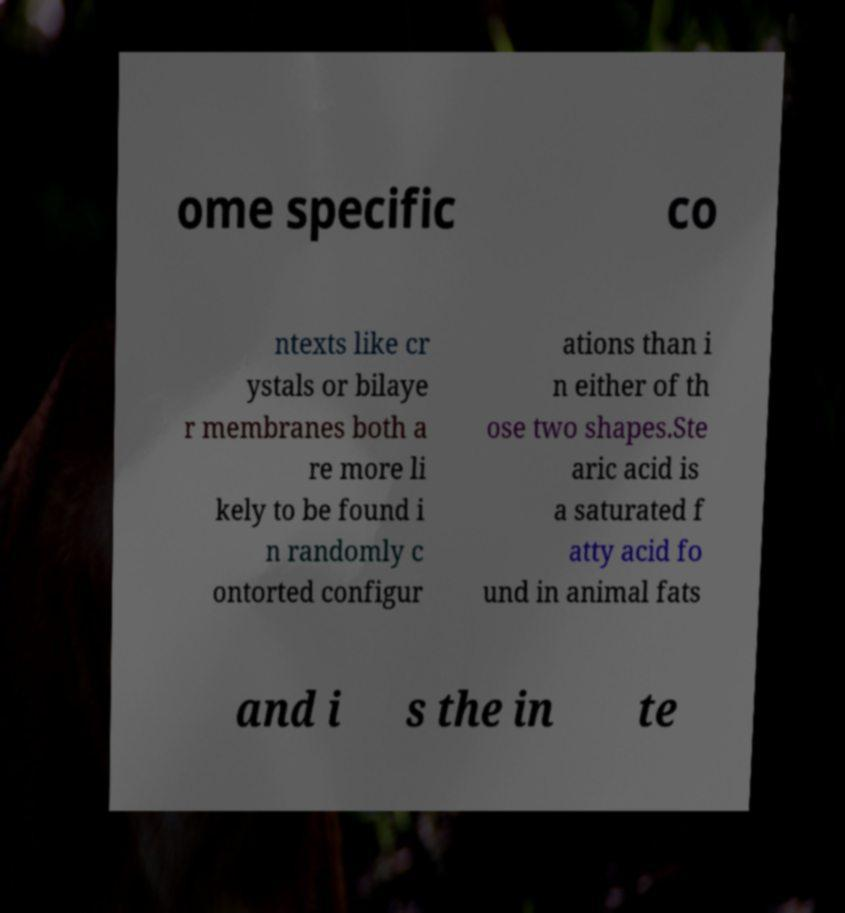Can you accurately transcribe the text from the provided image for me? ome specific co ntexts like cr ystals or bilaye r membranes both a re more li kely to be found i n randomly c ontorted configur ations than i n either of th ose two shapes.Ste aric acid is a saturated f atty acid fo und in animal fats and i s the in te 